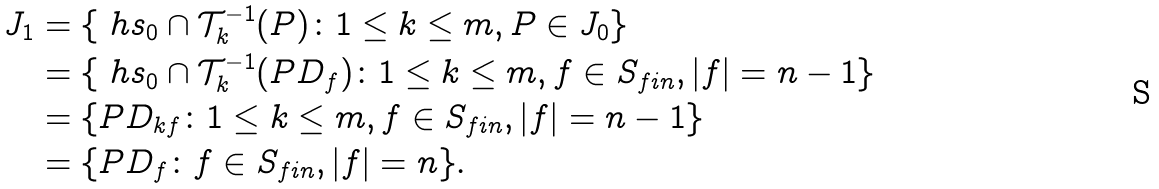Convert formula to latex. <formula><loc_0><loc_0><loc_500><loc_500>J _ { 1 } & = \{ \ h s _ { 0 } \cap \mathcal { T } _ { k } ^ { - 1 } ( P ) \colon 1 \leq k \leq m , P \in J _ { 0 } \} \\ & = \{ \ h s _ { 0 } \cap \mathcal { T } _ { k } ^ { - 1 } ( P D _ { f } ) \colon 1 \leq k \leq m , f \in S _ { f i n } , | f | = n - 1 \} \\ & = \{ P D _ { k f } \colon 1 \leq k \leq m , f \in S _ { f i n } , | f | = n - 1 \} \\ & = \{ P D _ { f } \colon f \in S _ { f i n } , | f | = n \} .</formula> 